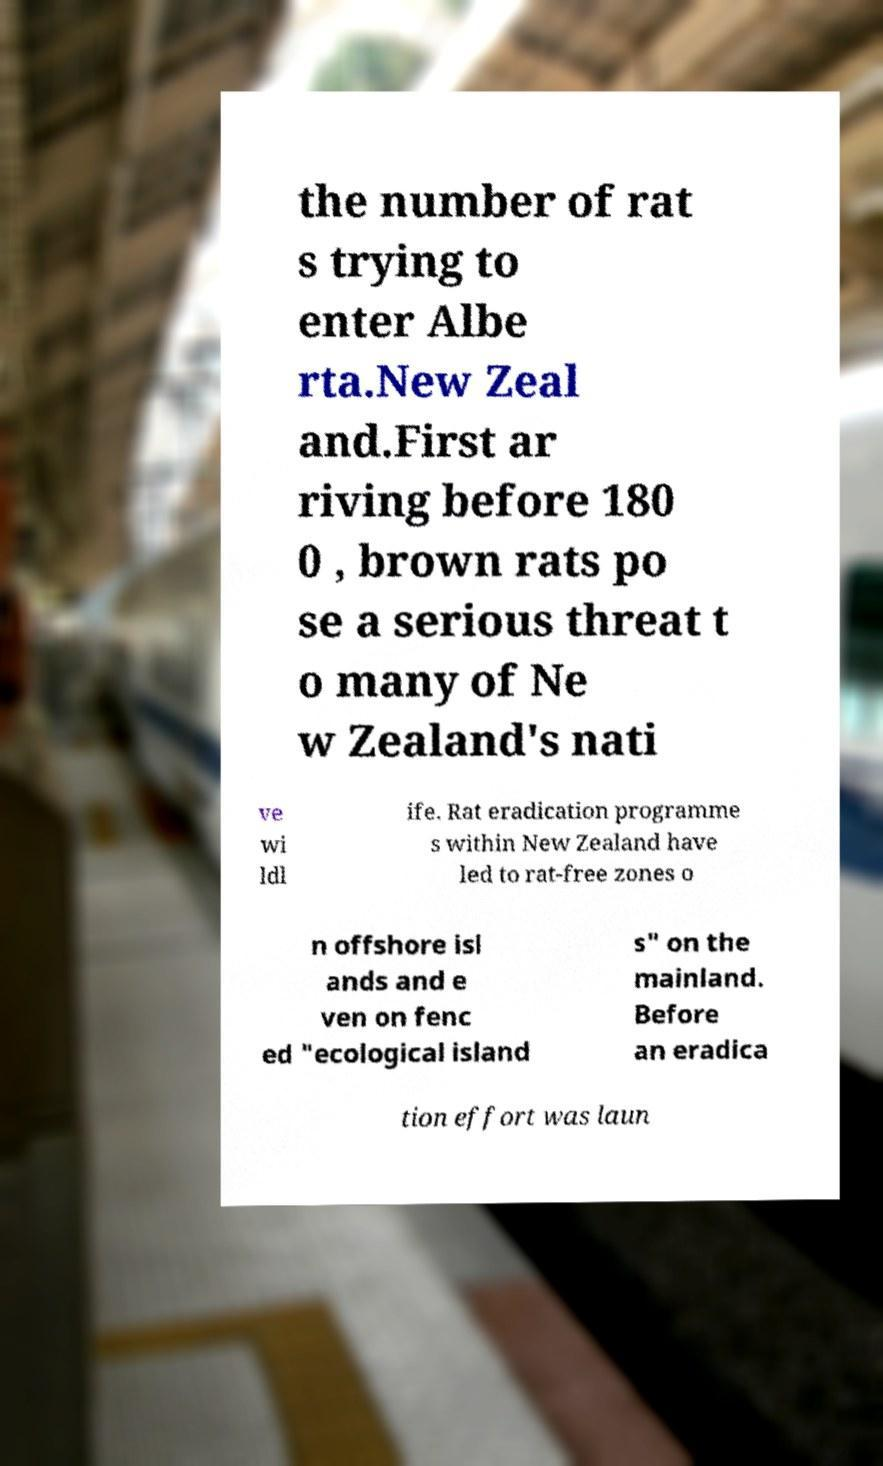Could you extract and type out the text from this image? the number of rat s trying to enter Albe rta.New Zeal and.First ar riving before 180 0 , brown rats po se a serious threat t o many of Ne w Zealand's nati ve wi ldl ife. Rat eradication programme s within New Zealand have led to rat-free zones o n offshore isl ands and e ven on fenc ed "ecological island s" on the mainland. Before an eradica tion effort was laun 